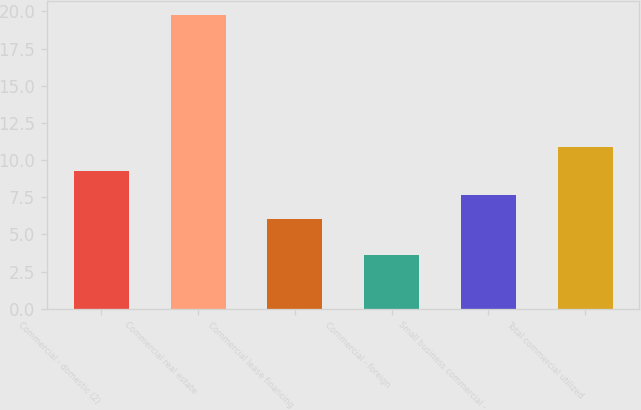Convert chart to OTSL. <chart><loc_0><loc_0><loc_500><loc_500><bar_chart><fcel>Commercial - domestic (2)<fcel>Commercial real estate<fcel>Commercial lease financing<fcel>Commercial - foreign<fcel>Small business commercial -<fcel>Total commercial utilized<nl><fcel>9.25<fcel>19.73<fcel>6.03<fcel>3.65<fcel>7.64<fcel>10.86<nl></chart> 